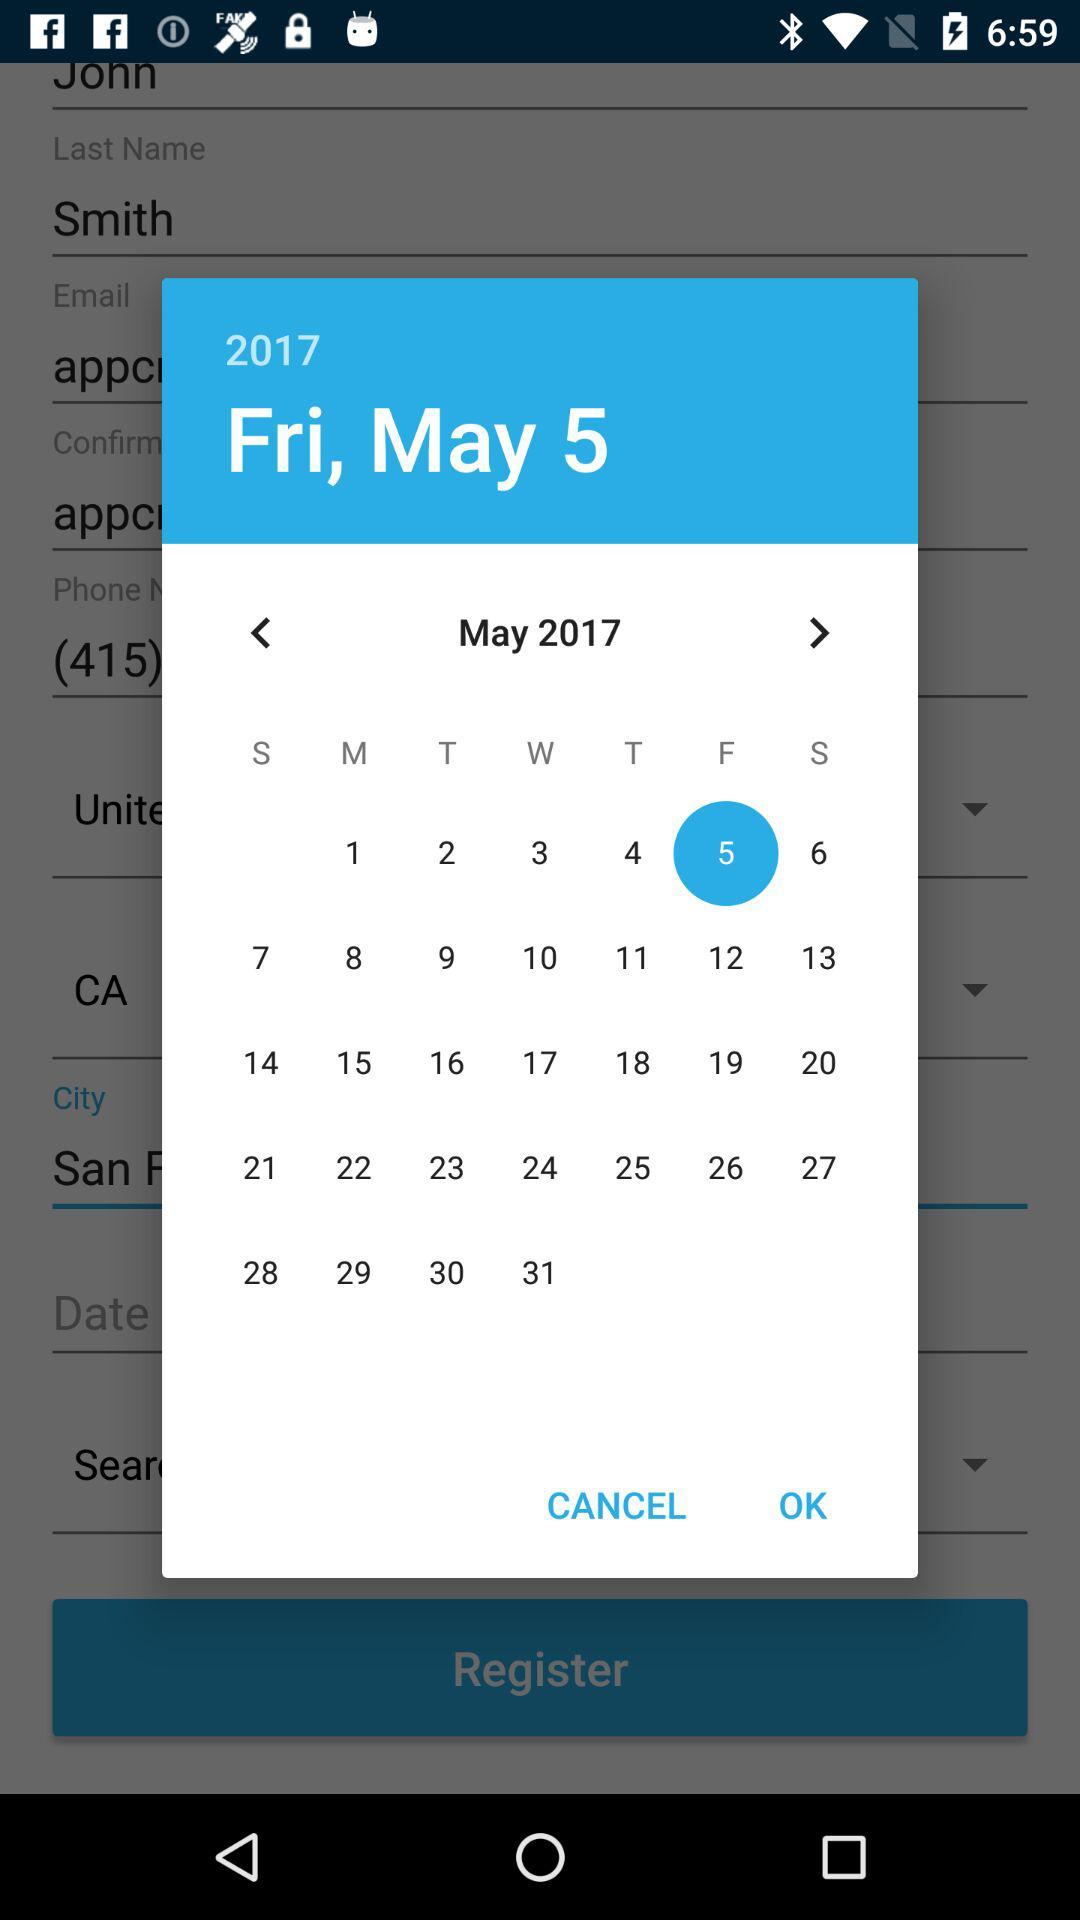What year's calendar is it? It is the 2017 calendar. 